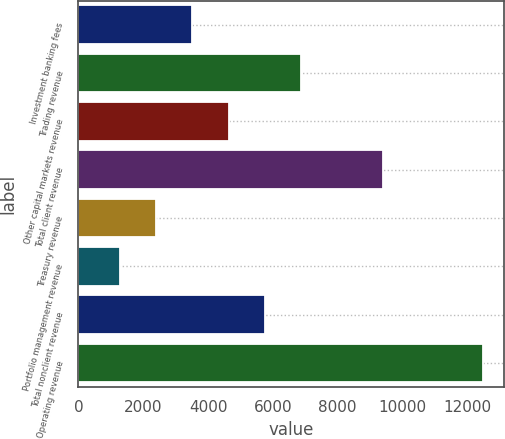<chart> <loc_0><loc_0><loc_500><loc_500><bar_chart><fcel>Investment banking fees<fcel>Trading revenue<fcel>Other capital markets revenue<fcel>Total client revenue<fcel>Treasury revenue<fcel>Portfolio management revenue<fcel>Total nonclient revenue<fcel>Operating revenue<nl><fcel>3517.2<fcel>6885<fcel>4639.8<fcel>9411<fcel>2394.6<fcel>1272<fcel>5762.4<fcel>12498<nl></chart> 